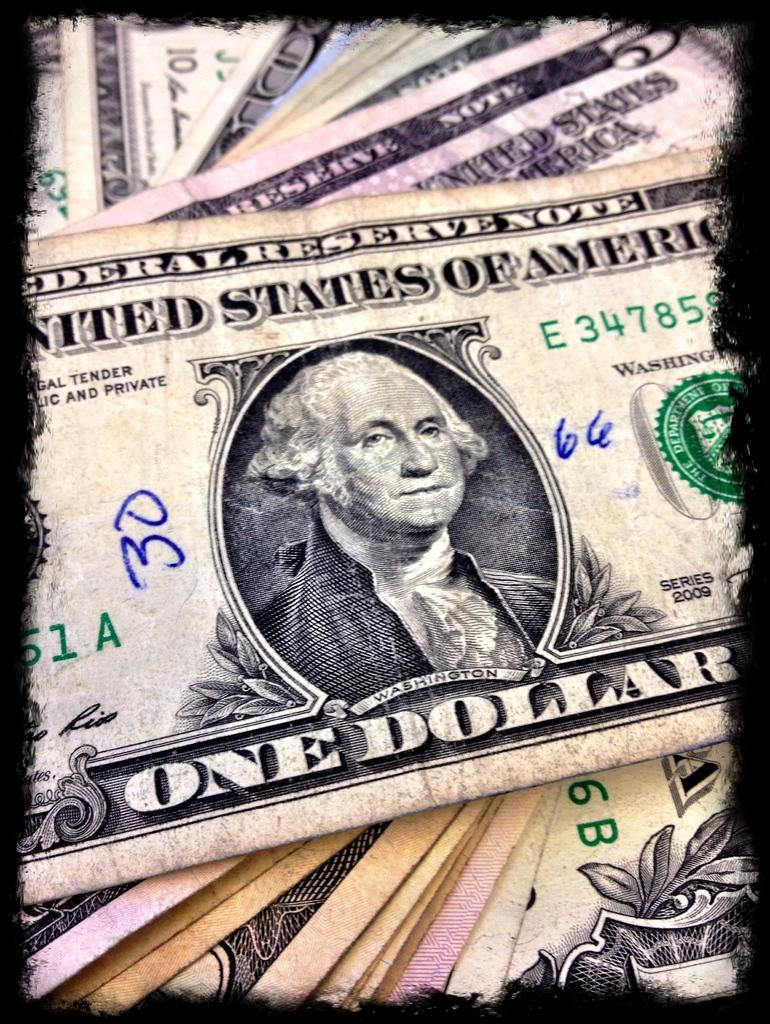In one or two sentences, can you explain what this image depicts? In this image we can see the currency notes with some text and picture. 